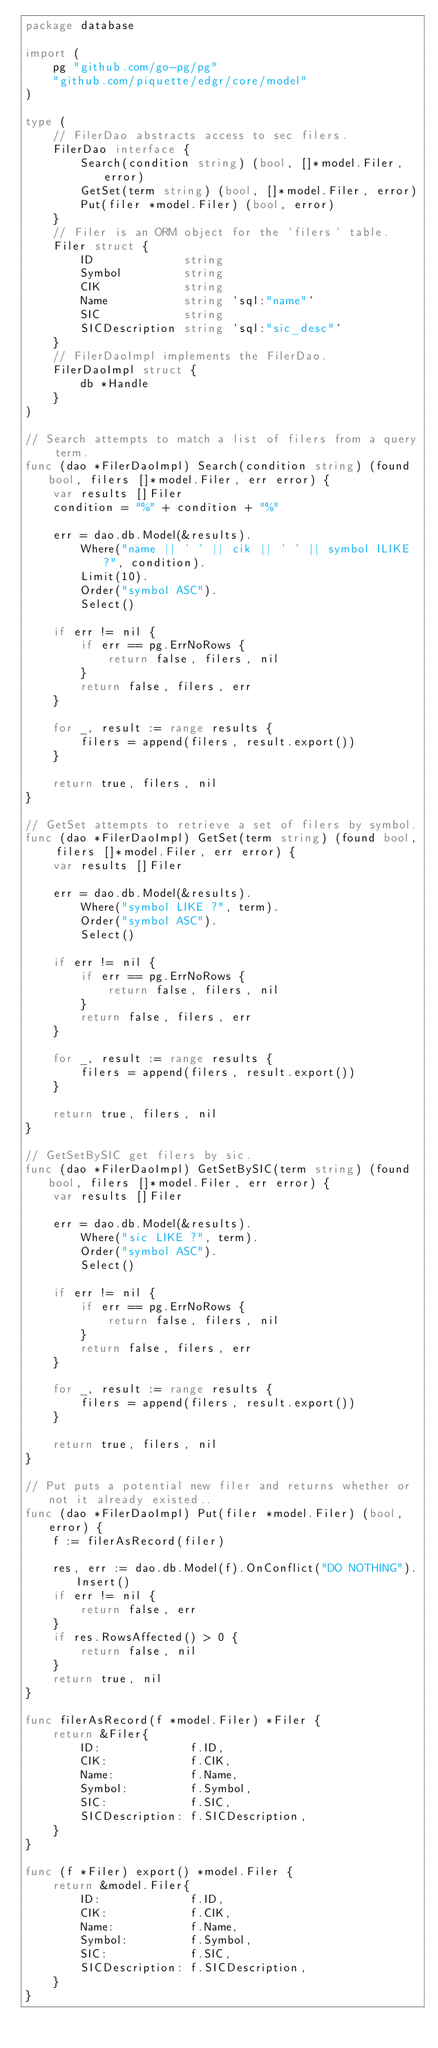<code> <loc_0><loc_0><loc_500><loc_500><_Go_>package database

import (
	pg "github.com/go-pg/pg"
	"github.com/piquette/edgr/core/model"
)

type (
	// FilerDao abstracts access to sec filers.
	FilerDao interface {
		Search(condition string) (bool, []*model.Filer, error)
		GetSet(term string) (bool, []*model.Filer, error)
		Put(filer *model.Filer) (bool, error)
	}
	// Filer is an ORM object for the `filers` table.
	Filer struct {
		ID             string
		Symbol         string
		CIK            string
		Name           string `sql:"name"`
		SIC            string
		SICDescription string `sql:"sic_desc"`
	}
	// FilerDaoImpl implements the FilerDao.
	FilerDaoImpl struct {
		db *Handle
	}
)

// Search attempts to match a list of filers from a query term.
func (dao *FilerDaoImpl) Search(condition string) (found bool, filers []*model.Filer, err error) {
	var results []Filer
	condition = "%" + condition + "%"

	err = dao.db.Model(&results).
		Where("name || ' ' || cik || ' ' || symbol ILIKE ?", condition).
		Limit(10).
		Order("symbol ASC").
		Select()

	if err != nil {
		if err == pg.ErrNoRows {
			return false, filers, nil
		}
		return false, filers, err
	}

	for _, result := range results {
		filers = append(filers, result.export())
	}

	return true, filers, nil
}

// GetSet attempts to retrieve a set of filers by symbol.
func (dao *FilerDaoImpl) GetSet(term string) (found bool, filers []*model.Filer, err error) {
	var results []Filer

	err = dao.db.Model(&results).
		Where("symbol LIKE ?", term).
		Order("symbol ASC").
		Select()

	if err != nil {
		if err == pg.ErrNoRows {
			return false, filers, nil
		}
		return false, filers, err
	}

	for _, result := range results {
		filers = append(filers, result.export())
	}

	return true, filers, nil
}

// GetSetBySIC get filers by sic.
func (dao *FilerDaoImpl) GetSetBySIC(term string) (found bool, filers []*model.Filer, err error) {
	var results []Filer

	err = dao.db.Model(&results).
		Where("sic LIKE ?", term).
		Order("symbol ASC").
		Select()

	if err != nil {
		if err == pg.ErrNoRows {
			return false, filers, nil
		}
		return false, filers, err
	}

	for _, result := range results {
		filers = append(filers, result.export())
	}

	return true, filers, nil
}

// Put puts a potential new filer and returns whether or not it already existed..
func (dao *FilerDaoImpl) Put(filer *model.Filer) (bool, error) {
	f := filerAsRecord(filer)

	res, err := dao.db.Model(f).OnConflict("DO NOTHING").Insert()
	if err != nil {
		return false, err
	}
	if res.RowsAffected() > 0 {
		return false, nil
	}
	return true, nil
}

func filerAsRecord(f *model.Filer) *Filer {
	return &Filer{
		ID:             f.ID,
		CIK:            f.CIK,
		Name:           f.Name,
		Symbol:         f.Symbol,
		SIC:            f.SIC,
		SICDescription: f.SICDescription,
	}
}

func (f *Filer) export() *model.Filer {
	return &model.Filer{
		ID:             f.ID,
		CIK:            f.CIK,
		Name:           f.Name,
		Symbol:         f.Symbol,
		SIC:            f.SIC,
		SICDescription: f.SICDescription,
	}
}
</code> 